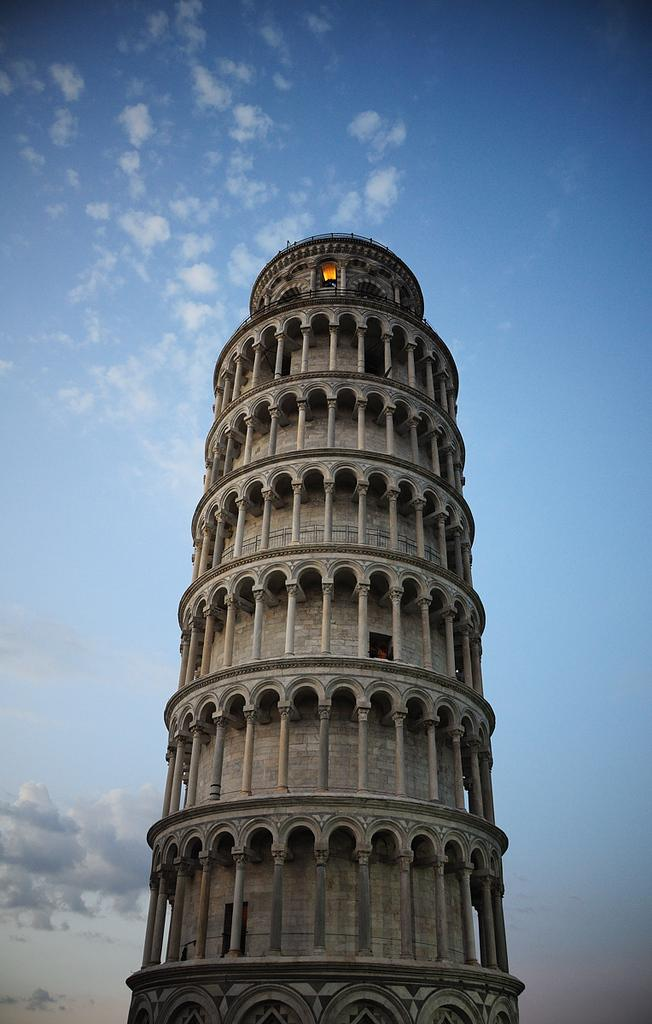What type of structure is present in the image? There is a building in the image. What can be seen in the background of the image? The sky is visible in the background of the image. What is the condition of the sky in the image? There are clouds in the sky. Can you see a crown on top of the building in the image? There is no crown visible on top of the building in the image. How many spiders are crawling on the building in the image? There are no spiders present in the image. 